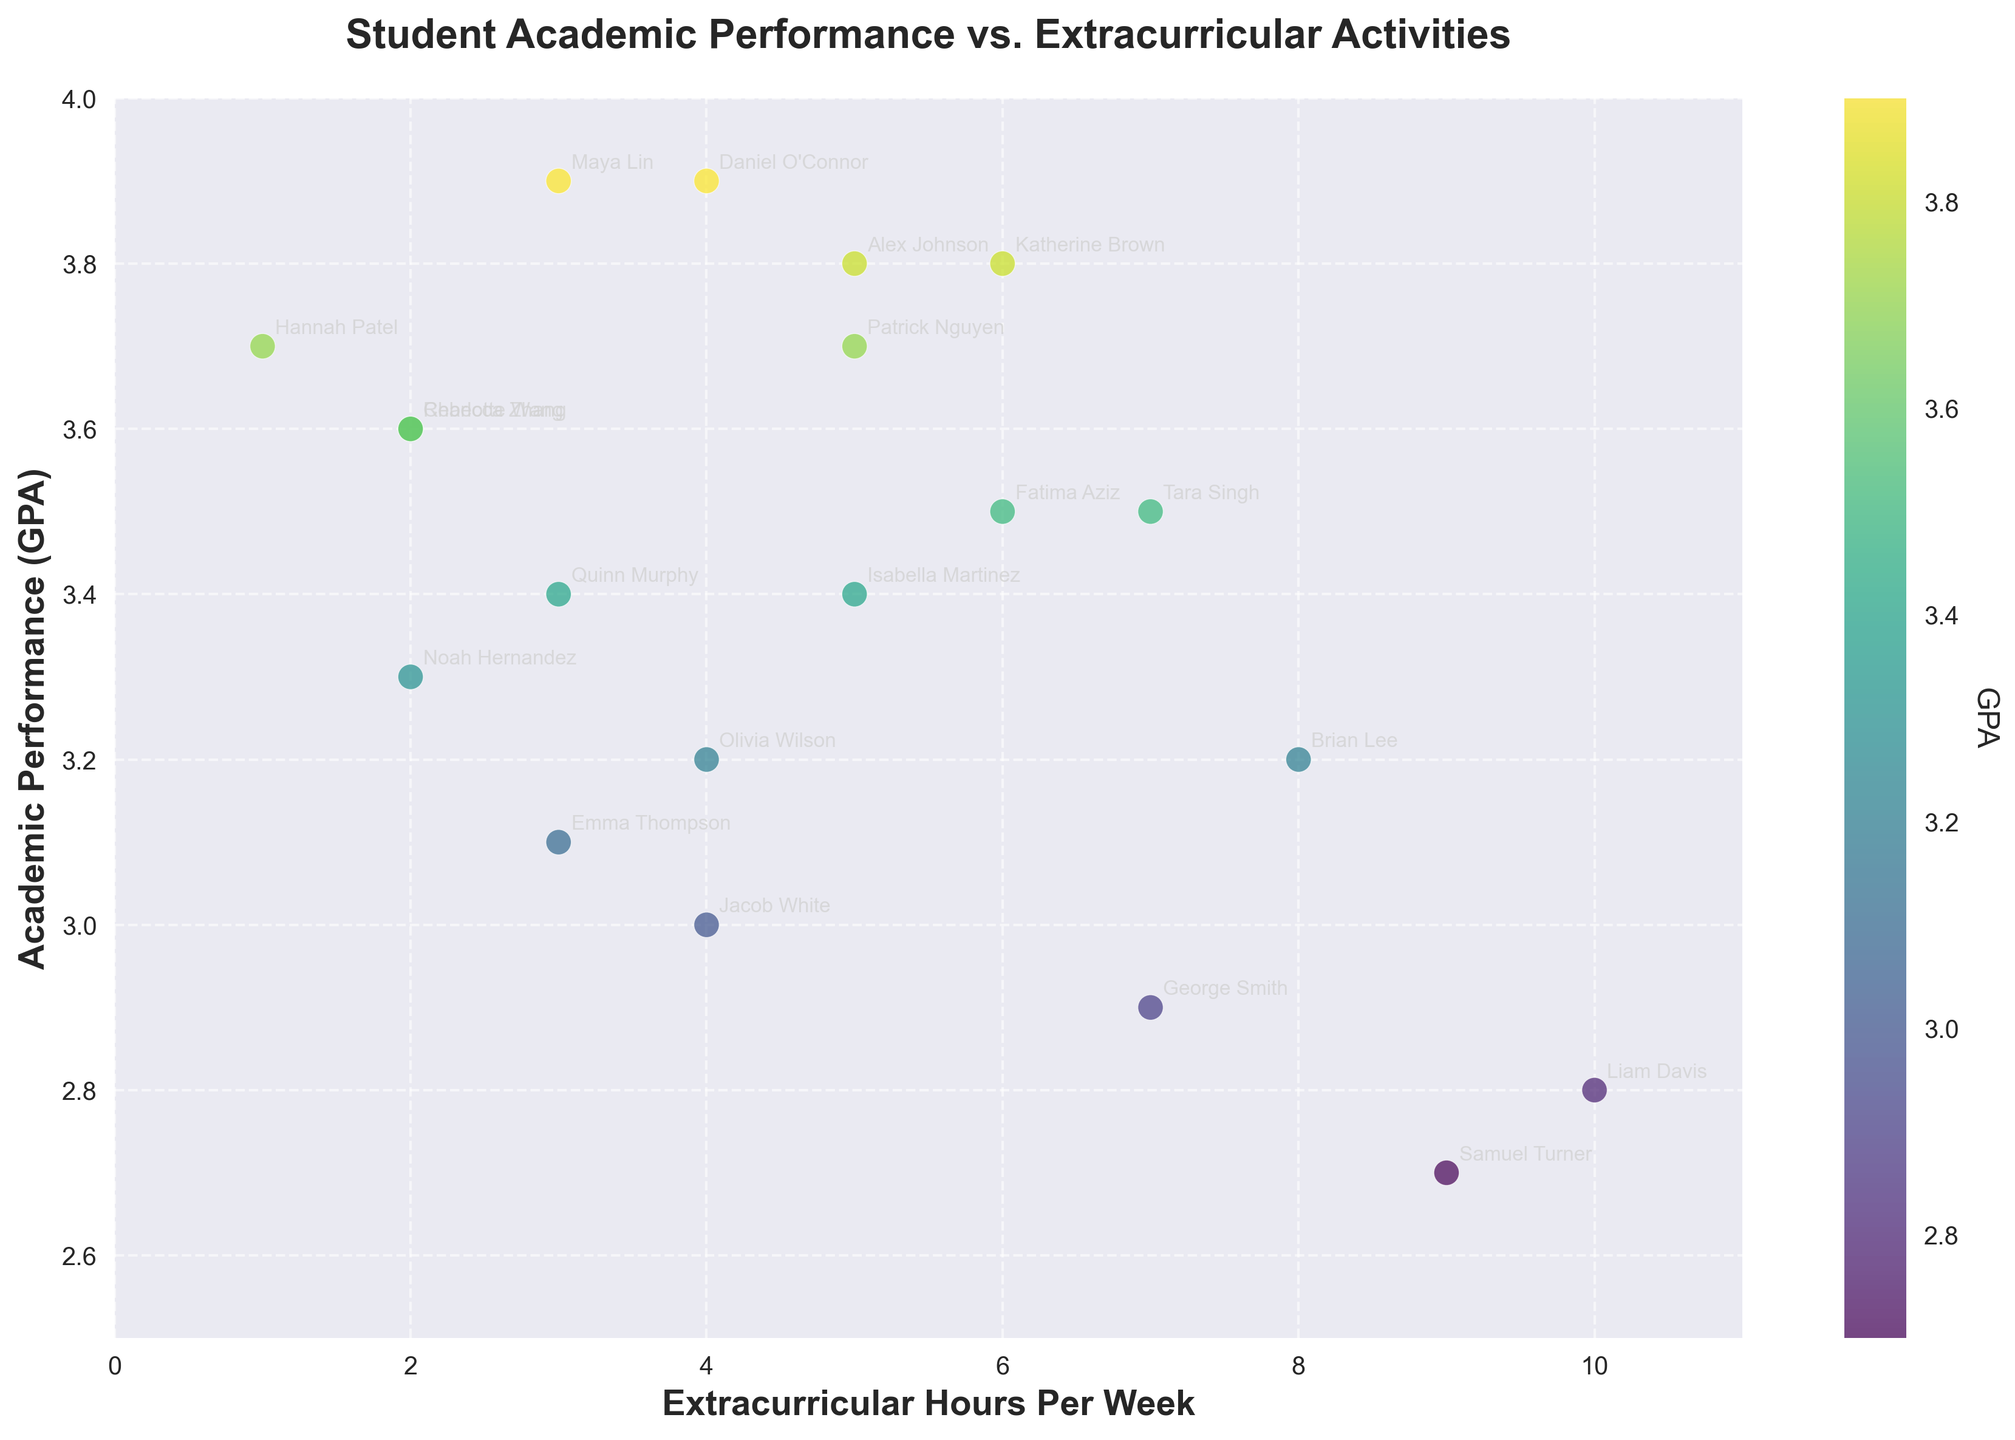What is the title of the scatter plot? The title of the scatter plot is located at the top of the graph and is typically large and bold for easy identification.
Answer: Student Academic Performance vs. Extracurricular Activities How many students have GPAs higher than 3.5? Count the data points (colored dots) that are above the 3.5 mark on the y-axis.
Answer: 9 Who spends the most hours per week in extracurricular activities, and what is their GPA? Identify the data point farthest to the right on the x-axis (Extracurricular Hours Per Week) and note the corresponding y-axis value (GPA) and the labeled student's name.
Answer: Liam Davis, 2.8 What's the average GPA of students participating in 4 hours/week of extracurricular activities? Identify the data points with x-values of 4 hours/week, sum their GPAs, and divide by the number of such data points.
Answer: (3.9 + 3.0 + 3.2) / 3 = 3.37 Which student has the highest GPA, and how many extracurricular hours do they participate in? Locate the data point highest on the y-axis for the highest GPA and read the corresponding x-axis value for extracurricular hours.
Answer: Daniel O'Connor, 4 hours What is the relationship between extracurricular hours and GPA for most students? Observe the overall trend of the data points. If most higher GPAs align with lower hours and vice versa, it indicates a negative relationship, and if higher GPAs align with higher hours, it indicates a positive relationship.
Answer: Generally, no clear correlation Which student has the lowest GPA, and how many extracurricular hours do they participate in? Identify the data point lowest on the y-axis for the lowest GPA and read the corresponding x-axis value for extracurricular hours, and note the labeled student's name.
Answer: Samuel Turner, 9 hours Are there any students with both high extracurricular hours (above 7) and high GPA (above 3.5)? Identify any data points where both conditions (x > 7 and y > 3.5) are met and note the corresponding student's names.
Answer: None How does Emma Thompson's GPA compare to Patrick Nguyen's GPA? Find the data points for Emma Thompson and Patrick Nguyen and compare their y-axis values (GPAs).
Answer: Emma: 3.1, Patrick: 3.7 What can be inferred from the color gradient in the scatter plot in relation to GPAs? The color gradient represents different GPA values; identify how the color changes correlate with GPA values.
Answer: Lighter colors indicate higher GPAs, while darker colors indicate lower GPAs 